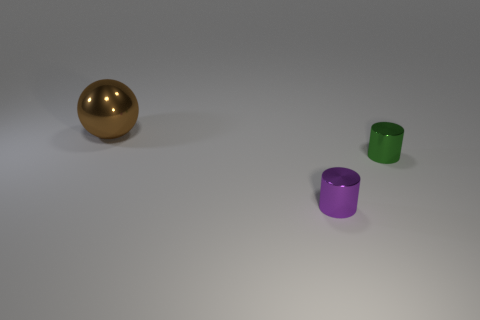Subtract all cylinders. How many objects are left? 1 Add 1 green metal things. How many objects exist? 4 Subtract all metal things. Subtract all small yellow cubes. How many objects are left? 0 Add 3 metallic balls. How many metallic balls are left? 4 Add 1 purple metal objects. How many purple metal objects exist? 2 Subtract 0 blue balls. How many objects are left? 3 